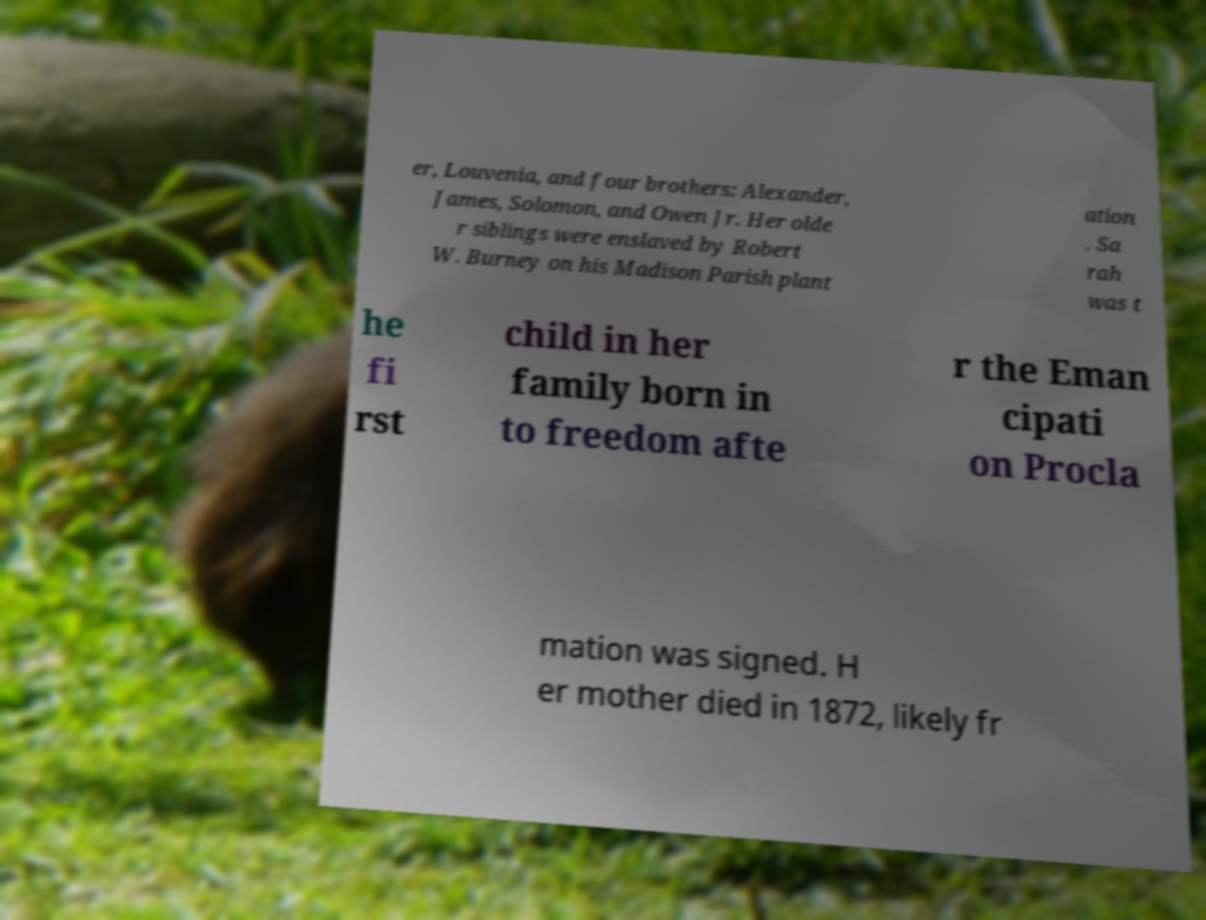Please read and relay the text visible in this image. What does it say? er, Louvenia, and four brothers: Alexander, James, Solomon, and Owen Jr. Her olde r siblings were enslaved by Robert W. Burney on his Madison Parish plant ation . Sa rah was t he fi rst child in her family born in to freedom afte r the Eman cipati on Procla mation was signed. H er mother died in 1872, likely fr 